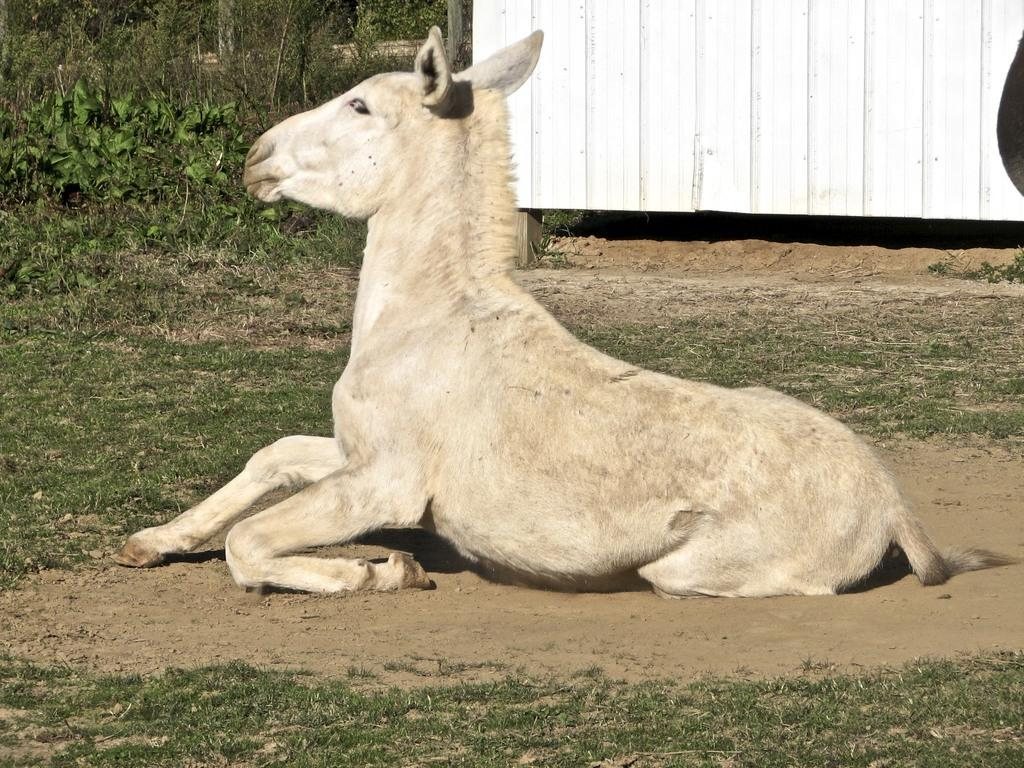What is the main subject of the image? There is an animal sitting on the ground in the image. What can be seen in the background of the image? There is a white object in the background of the image. What type of vegetation is visible in the image? There are plants visible in the image. What is the ground made of in the image? There is grass on the ground in the image. What is the manager's role in the image? There is no manager present in the image, as it features an animal sitting on the ground with plants and grass in the background. 